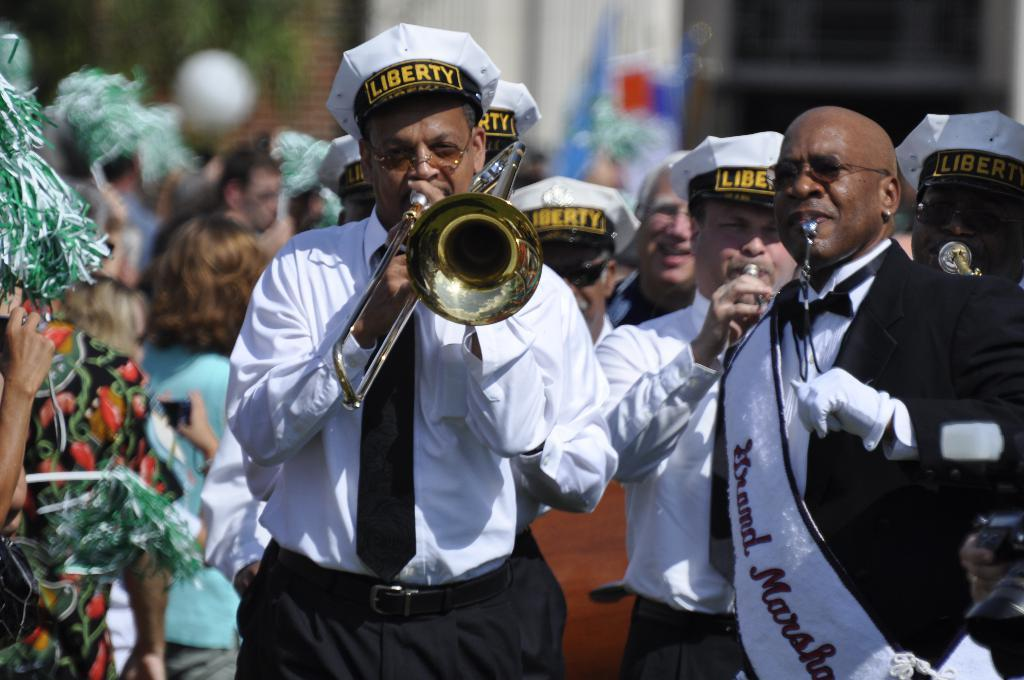How many people are in the image? There are people in the image, but the exact number is not specified. What are some of the people doing in the image? Some of the people are playing musical instruments. What type of meal is being prepared by the queen in the image? There is no queen or meal preparation present in the image. What type of slip is visible on the floor in the image? There is no slip visible on the floor in the image. 